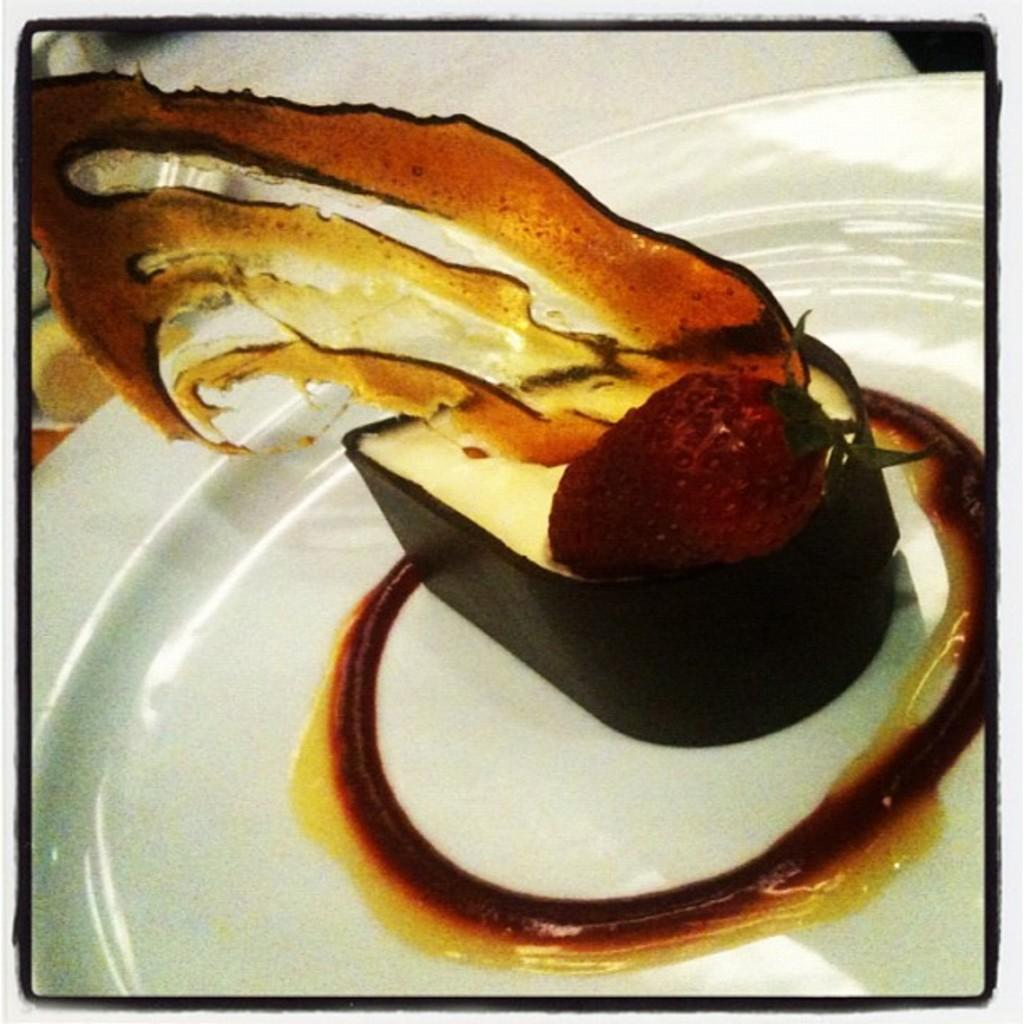What is in the center of the image? There is a plate in the center of the image. What is on the plate? The plate contains dessert. Can you describe the dessert on the plate? There is a strawberry on the dessert. What type of shoes is the beggar wearing in the image? There is no beggar or shoes present in the image; it only features a plate with dessert and a strawberry. 